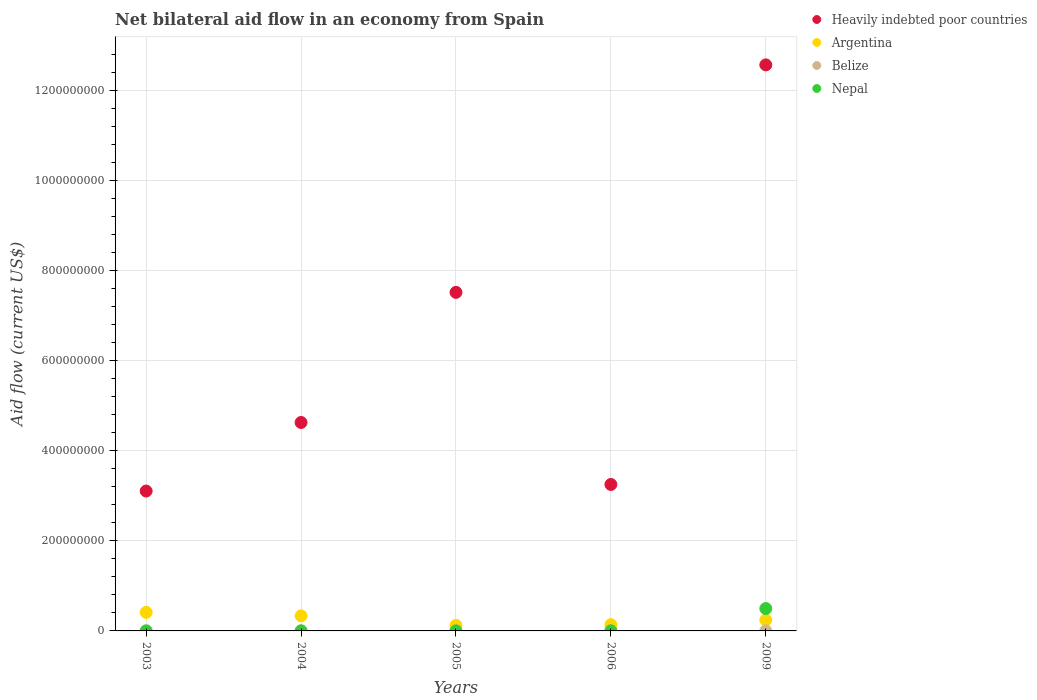How many different coloured dotlines are there?
Make the answer very short. 4. Across all years, what is the maximum net bilateral aid flow in Heavily indebted poor countries?
Your response must be concise. 1.26e+09. Across all years, what is the minimum net bilateral aid flow in Belize?
Your response must be concise. 0. In which year was the net bilateral aid flow in Nepal maximum?
Your answer should be very brief. 2009. What is the total net bilateral aid flow in Nepal in the graph?
Make the answer very short. 5.00e+07. What is the difference between the net bilateral aid flow in Nepal in 2003 and that in 2009?
Your answer should be compact. -4.96e+07. What is the difference between the net bilateral aid flow in Nepal in 2006 and the net bilateral aid flow in Heavily indebted poor countries in 2009?
Your answer should be compact. -1.26e+09. What is the average net bilateral aid flow in Nepal per year?
Make the answer very short. 1.00e+07. In the year 2005, what is the difference between the net bilateral aid flow in Belize and net bilateral aid flow in Argentina?
Make the answer very short. -1.21e+07. What is the ratio of the net bilateral aid flow in Nepal in 2004 to that in 2006?
Provide a succinct answer. 0.47. Is the net bilateral aid flow in Heavily indebted poor countries in 2006 less than that in 2009?
Give a very brief answer. Yes. Is the difference between the net bilateral aid flow in Belize in 2004 and 2006 greater than the difference between the net bilateral aid flow in Argentina in 2004 and 2006?
Ensure brevity in your answer.  No. What is the difference between the highest and the second highest net bilateral aid flow in Nepal?
Offer a very short reply. 4.94e+07. What is the difference between the highest and the lowest net bilateral aid flow in Nepal?
Offer a very short reply. 4.96e+07. In how many years, is the net bilateral aid flow in Argentina greater than the average net bilateral aid flow in Argentina taken over all years?
Ensure brevity in your answer.  2. Is it the case that in every year, the sum of the net bilateral aid flow in Argentina and net bilateral aid flow in Belize  is greater than the net bilateral aid flow in Heavily indebted poor countries?
Your response must be concise. No. How many dotlines are there?
Your answer should be compact. 4. Are the values on the major ticks of Y-axis written in scientific E-notation?
Give a very brief answer. No. Where does the legend appear in the graph?
Keep it short and to the point. Top right. How many legend labels are there?
Your answer should be compact. 4. What is the title of the graph?
Give a very brief answer. Net bilateral aid flow in an economy from Spain. Does "Aruba" appear as one of the legend labels in the graph?
Provide a short and direct response. No. What is the label or title of the X-axis?
Provide a short and direct response. Years. What is the label or title of the Y-axis?
Your answer should be compact. Aid flow (current US$). What is the Aid flow (current US$) in Heavily indebted poor countries in 2003?
Your response must be concise. 3.11e+08. What is the Aid flow (current US$) in Argentina in 2003?
Your response must be concise. 4.12e+07. What is the Aid flow (current US$) of Heavily indebted poor countries in 2004?
Make the answer very short. 4.63e+08. What is the Aid flow (current US$) of Argentina in 2004?
Provide a short and direct response. 3.34e+07. What is the Aid flow (current US$) of Heavily indebted poor countries in 2005?
Provide a short and direct response. 7.52e+08. What is the Aid flow (current US$) in Argentina in 2005?
Give a very brief answer. 1.23e+07. What is the Aid flow (current US$) in Nepal in 2005?
Provide a short and direct response. 1.00e+05. What is the Aid flow (current US$) of Heavily indebted poor countries in 2006?
Provide a succinct answer. 3.25e+08. What is the Aid flow (current US$) in Argentina in 2006?
Your response must be concise. 1.38e+07. What is the Aid flow (current US$) in Belize in 2006?
Offer a terse response. 2.00e+04. What is the Aid flow (current US$) of Nepal in 2006?
Offer a very short reply. 1.90e+05. What is the Aid flow (current US$) in Heavily indebted poor countries in 2009?
Your response must be concise. 1.26e+09. What is the Aid flow (current US$) of Argentina in 2009?
Your answer should be very brief. 2.41e+07. What is the Aid flow (current US$) in Belize in 2009?
Keep it short and to the point. 2.90e+05. What is the Aid flow (current US$) of Nepal in 2009?
Offer a very short reply. 4.96e+07. Across all years, what is the maximum Aid flow (current US$) of Heavily indebted poor countries?
Provide a short and direct response. 1.26e+09. Across all years, what is the maximum Aid flow (current US$) in Argentina?
Provide a succinct answer. 4.12e+07. Across all years, what is the maximum Aid flow (current US$) of Nepal?
Your answer should be compact. 4.96e+07. Across all years, what is the minimum Aid flow (current US$) in Heavily indebted poor countries?
Ensure brevity in your answer.  3.11e+08. Across all years, what is the minimum Aid flow (current US$) in Argentina?
Provide a succinct answer. 1.23e+07. Across all years, what is the minimum Aid flow (current US$) in Belize?
Keep it short and to the point. 0. What is the total Aid flow (current US$) in Heavily indebted poor countries in the graph?
Ensure brevity in your answer.  3.11e+09. What is the total Aid flow (current US$) of Argentina in the graph?
Offer a very short reply. 1.25e+08. What is the total Aid flow (current US$) of Belize in the graph?
Offer a very short reply. 7.40e+05. What is the total Aid flow (current US$) in Nepal in the graph?
Keep it short and to the point. 5.00e+07. What is the difference between the Aid flow (current US$) of Heavily indebted poor countries in 2003 and that in 2004?
Keep it short and to the point. -1.52e+08. What is the difference between the Aid flow (current US$) of Argentina in 2003 and that in 2004?
Provide a succinct answer. 7.77e+06. What is the difference between the Aid flow (current US$) in Heavily indebted poor countries in 2003 and that in 2005?
Make the answer very short. -4.41e+08. What is the difference between the Aid flow (current US$) of Argentina in 2003 and that in 2005?
Provide a succinct answer. 2.88e+07. What is the difference between the Aid flow (current US$) of Heavily indebted poor countries in 2003 and that in 2006?
Provide a succinct answer. -1.46e+07. What is the difference between the Aid flow (current US$) of Argentina in 2003 and that in 2006?
Provide a succinct answer. 2.73e+07. What is the difference between the Aid flow (current US$) in Heavily indebted poor countries in 2003 and that in 2009?
Your answer should be very brief. -9.46e+08. What is the difference between the Aid flow (current US$) in Argentina in 2003 and that in 2009?
Keep it short and to the point. 1.70e+07. What is the difference between the Aid flow (current US$) in Nepal in 2003 and that in 2009?
Your answer should be very brief. -4.96e+07. What is the difference between the Aid flow (current US$) in Heavily indebted poor countries in 2004 and that in 2005?
Keep it short and to the point. -2.89e+08. What is the difference between the Aid flow (current US$) in Argentina in 2004 and that in 2005?
Make the answer very short. 2.11e+07. What is the difference between the Aid flow (current US$) in Nepal in 2004 and that in 2005?
Keep it short and to the point. -10000. What is the difference between the Aid flow (current US$) of Heavily indebted poor countries in 2004 and that in 2006?
Your answer should be very brief. 1.38e+08. What is the difference between the Aid flow (current US$) in Argentina in 2004 and that in 2006?
Keep it short and to the point. 1.96e+07. What is the difference between the Aid flow (current US$) in Belize in 2004 and that in 2006?
Ensure brevity in your answer.  1.60e+05. What is the difference between the Aid flow (current US$) of Nepal in 2004 and that in 2006?
Your answer should be compact. -1.00e+05. What is the difference between the Aid flow (current US$) in Heavily indebted poor countries in 2004 and that in 2009?
Provide a succinct answer. -7.94e+08. What is the difference between the Aid flow (current US$) of Argentina in 2004 and that in 2009?
Your response must be concise. 9.25e+06. What is the difference between the Aid flow (current US$) in Belize in 2004 and that in 2009?
Ensure brevity in your answer.  -1.10e+05. What is the difference between the Aid flow (current US$) of Nepal in 2004 and that in 2009?
Give a very brief answer. -4.95e+07. What is the difference between the Aid flow (current US$) of Heavily indebted poor countries in 2005 and that in 2006?
Your answer should be very brief. 4.26e+08. What is the difference between the Aid flow (current US$) in Argentina in 2005 and that in 2006?
Ensure brevity in your answer.  -1.50e+06. What is the difference between the Aid flow (current US$) in Heavily indebted poor countries in 2005 and that in 2009?
Give a very brief answer. -5.05e+08. What is the difference between the Aid flow (current US$) of Argentina in 2005 and that in 2009?
Offer a very short reply. -1.18e+07. What is the difference between the Aid flow (current US$) of Nepal in 2005 and that in 2009?
Make the answer very short. -4.95e+07. What is the difference between the Aid flow (current US$) in Heavily indebted poor countries in 2006 and that in 2009?
Ensure brevity in your answer.  -9.31e+08. What is the difference between the Aid flow (current US$) of Argentina in 2006 and that in 2009?
Your answer should be compact. -1.03e+07. What is the difference between the Aid flow (current US$) in Nepal in 2006 and that in 2009?
Ensure brevity in your answer.  -4.94e+07. What is the difference between the Aid flow (current US$) in Heavily indebted poor countries in 2003 and the Aid flow (current US$) in Argentina in 2004?
Your answer should be compact. 2.77e+08. What is the difference between the Aid flow (current US$) of Heavily indebted poor countries in 2003 and the Aid flow (current US$) of Belize in 2004?
Your response must be concise. 3.10e+08. What is the difference between the Aid flow (current US$) of Heavily indebted poor countries in 2003 and the Aid flow (current US$) of Nepal in 2004?
Keep it short and to the point. 3.10e+08. What is the difference between the Aid flow (current US$) of Argentina in 2003 and the Aid flow (current US$) of Belize in 2004?
Provide a short and direct response. 4.10e+07. What is the difference between the Aid flow (current US$) of Argentina in 2003 and the Aid flow (current US$) of Nepal in 2004?
Offer a very short reply. 4.11e+07. What is the difference between the Aid flow (current US$) in Heavily indebted poor countries in 2003 and the Aid flow (current US$) in Argentina in 2005?
Give a very brief answer. 2.98e+08. What is the difference between the Aid flow (current US$) in Heavily indebted poor countries in 2003 and the Aid flow (current US$) in Belize in 2005?
Provide a short and direct response. 3.10e+08. What is the difference between the Aid flow (current US$) in Heavily indebted poor countries in 2003 and the Aid flow (current US$) in Nepal in 2005?
Ensure brevity in your answer.  3.10e+08. What is the difference between the Aid flow (current US$) of Argentina in 2003 and the Aid flow (current US$) of Belize in 2005?
Your answer should be very brief. 4.09e+07. What is the difference between the Aid flow (current US$) of Argentina in 2003 and the Aid flow (current US$) of Nepal in 2005?
Your answer should be very brief. 4.11e+07. What is the difference between the Aid flow (current US$) of Heavily indebted poor countries in 2003 and the Aid flow (current US$) of Argentina in 2006?
Provide a succinct answer. 2.97e+08. What is the difference between the Aid flow (current US$) of Heavily indebted poor countries in 2003 and the Aid flow (current US$) of Belize in 2006?
Provide a succinct answer. 3.10e+08. What is the difference between the Aid flow (current US$) in Heavily indebted poor countries in 2003 and the Aid flow (current US$) in Nepal in 2006?
Your answer should be compact. 3.10e+08. What is the difference between the Aid flow (current US$) of Argentina in 2003 and the Aid flow (current US$) of Belize in 2006?
Provide a short and direct response. 4.11e+07. What is the difference between the Aid flow (current US$) in Argentina in 2003 and the Aid flow (current US$) in Nepal in 2006?
Keep it short and to the point. 4.10e+07. What is the difference between the Aid flow (current US$) of Heavily indebted poor countries in 2003 and the Aid flow (current US$) of Argentina in 2009?
Make the answer very short. 2.86e+08. What is the difference between the Aid flow (current US$) in Heavily indebted poor countries in 2003 and the Aid flow (current US$) in Belize in 2009?
Offer a terse response. 3.10e+08. What is the difference between the Aid flow (current US$) of Heavily indebted poor countries in 2003 and the Aid flow (current US$) of Nepal in 2009?
Your response must be concise. 2.61e+08. What is the difference between the Aid flow (current US$) in Argentina in 2003 and the Aid flow (current US$) in Belize in 2009?
Provide a short and direct response. 4.09e+07. What is the difference between the Aid flow (current US$) in Argentina in 2003 and the Aid flow (current US$) in Nepal in 2009?
Provide a succinct answer. -8.46e+06. What is the difference between the Aid flow (current US$) in Heavily indebted poor countries in 2004 and the Aid flow (current US$) in Argentina in 2005?
Provide a short and direct response. 4.50e+08. What is the difference between the Aid flow (current US$) of Heavily indebted poor countries in 2004 and the Aid flow (current US$) of Belize in 2005?
Ensure brevity in your answer.  4.62e+08. What is the difference between the Aid flow (current US$) of Heavily indebted poor countries in 2004 and the Aid flow (current US$) of Nepal in 2005?
Offer a terse response. 4.63e+08. What is the difference between the Aid flow (current US$) of Argentina in 2004 and the Aid flow (current US$) of Belize in 2005?
Offer a very short reply. 3.31e+07. What is the difference between the Aid flow (current US$) in Argentina in 2004 and the Aid flow (current US$) in Nepal in 2005?
Give a very brief answer. 3.33e+07. What is the difference between the Aid flow (current US$) in Heavily indebted poor countries in 2004 and the Aid flow (current US$) in Argentina in 2006?
Provide a succinct answer. 4.49e+08. What is the difference between the Aid flow (current US$) of Heavily indebted poor countries in 2004 and the Aid flow (current US$) of Belize in 2006?
Your answer should be compact. 4.63e+08. What is the difference between the Aid flow (current US$) in Heavily indebted poor countries in 2004 and the Aid flow (current US$) in Nepal in 2006?
Give a very brief answer. 4.62e+08. What is the difference between the Aid flow (current US$) in Argentina in 2004 and the Aid flow (current US$) in Belize in 2006?
Offer a very short reply. 3.34e+07. What is the difference between the Aid flow (current US$) of Argentina in 2004 and the Aid flow (current US$) of Nepal in 2006?
Provide a succinct answer. 3.32e+07. What is the difference between the Aid flow (current US$) in Heavily indebted poor countries in 2004 and the Aid flow (current US$) in Argentina in 2009?
Provide a succinct answer. 4.39e+08. What is the difference between the Aid flow (current US$) in Heavily indebted poor countries in 2004 and the Aid flow (current US$) in Belize in 2009?
Offer a terse response. 4.62e+08. What is the difference between the Aid flow (current US$) of Heavily indebted poor countries in 2004 and the Aid flow (current US$) of Nepal in 2009?
Provide a short and direct response. 4.13e+08. What is the difference between the Aid flow (current US$) in Argentina in 2004 and the Aid flow (current US$) in Belize in 2009?
Your response must be concise. 3.31e+07. What is the difference between the Aid flow (current US$) of Argentina in 2004 and the Aid flow (current US$) of Nepal in 2009?
Your response must be concise. -1.62e+07. What is the difference between the Aid flow (current US$) of Belize in 2004 and the Aid flow (current US$) of Nepal in 2009?
Make the answer very short. -4.94e+07. What is the difference between the Aid flow (current US$) in Heavily indebted poor countries in 2005 and the Aid flow (current US$) in Argentina in 2006?
Ensure brevity in your answer.  7.38e+08. What is the difference between the Aid flow (current US$) in Heavily indebted poor countries in 2005 and the Aid flow (current US$) in Belize in 2006?
Provide a succinct answer. 7.52e+08. What is the difference between the Aid flow (current US$) of Heavily indebted poor countries in 2005 and the Aid flow (current US$) of Nepal in 2006?
Your answer should be compact. 7.51e+08. What is the difference between the Aid flow (current US$) of Argentina in 2005 and the Aid flow (current US$) of Belize in 2006?
Your response must be concise. 1.23e+07. What is the difference between the Aid flow (current US$) of Argentina in 2005 and the Aid flow (current US$) of Nepal in 2006?
Give a very brief answer. 1.21e+07. What is the difference between the Aid flow (current US$) in Heavily indebted poor countries in 2005 and the Aid flow (current US$) in Argentina in 2009?
Provide a succinct answer. 7.27e+08. What is the difference between the Aid flow (current US$) of Heavily indebted poor countries in 2005 and the Aid flow (current US$) of Belize in 2009?
Offer a terse response. 7.51e+08. What is the difference between the Aid flow (current US$) of Heavily indebted poor countries in 2005 and the Aid flow (current US$) of Nepal in 2009?
Your response must be concise. 7.02e+08. What is the difference between the Aid flow (current US$) in Argentina in 2005 and the Aid flow (current US$) in Belize in 2009?
Your answer should be compact. 1.20e+07. What is the difference between the Aid flow (current US$) in Argentina in 2005 and the Aid flow (current US$) in Nepal in 2009?
Make the answer very short. -3.73e+07. What is the difference between the Aid flow (current US$) of Belize in 2005 and the Aid flow (current US$) of Nepal in 2009?
Make the answer very short. -4.94e+07. What is the difference between the Aid flow (current US$) in Heavily indebted poor countries in 2006 and the Aid flow (current US$) in Argentina in 2009?
Offer a terse response. 3.01e+08. What is the difference between the Aid flow (current US$) of Heavily indebted poor countries in 2006 and the Aid flow (current US$) of Belize in 2009?
Make the answer very short. 3.25e+08. What is the difference between the Aid flow (current US$) of Heavily indebted poor countries in 2006 and the Aid flow (current US$) of Nepal in 2009?
Provide a succinct answer. 2.75e+08. What is the difference between the Aid flow (current US$) in Argentina in 2006 and the Aid flow (current US$) in Belize in 2009?
Your answer should be compact. 1.35e+07. What is the difference between the Aid flow (current US$) in Argentina in 2006 and the Aid flow (current US$) in Nepal in 2009?
Keep it short and to the point. -3.58e+07. What is the difference between the Aid flow (current US$) in Belize in 2006 and the Aid flow (current US$) in Nepal in 2009?
Make the answer very short. -4.96e+07. What is the average Aid flow (current US$) of Heavily indebted poor countries per year?
Your answer should be compact. 6.21e+08. What is the average Aid flow (current US$) in Argentina per year?
Your answer should be very brief. 2.50e+07. What is the average Aid flow (current US$) in Belize per year?
Keep it short and to the point. 1.48e+05. What is the average Aid flow (current US$) in Nepal per year?
Offer a very short reply. 1.00e+07. In the year 2003, what is the difference between the Aid flow (current US$) in Heavily indebted poor countries and Aid flow (current US$) in Argentina?
Provide a succinct answer. 2.69e+08. In the year 2003, what is the difference between the Aid flow (current US$) in Heavily indebted poor countries and Aid flow (current US$) in Nepal?
Your response must be concise. 3.10e+08. In the year 2003, what is the difference between the Aid flow (current US$) of Argentina and Aid flow (current US$) of Nepal?
Your response must be concise. 4.11e+07. In the year 2004, what is the difference between the Aid flow (current US$) in Heavily indebted poor countries and Aid flow (current US$) in Argentina?
Your answer should be very brief. 4.29e+08. In the year 2004, what is the difference between the Aid flow (current US$) of Heavily indebted poor countries and Aid flow (current US$) of Belize?
Your answer should be compact. 4.62e+08. In the year 2004, what is the difference between the Aid flow (current US$) of Heavily indebted poor countries and Aid flow (current US$) of Nepal?
Keep it short and to the point. 4.63e+08. In the year 2004, what is the difference between the Aid flow (current US$) of Argentina and Aid flow (current US$) of Belize?
Make the answer very short. 3.32e+07. In the year 2004, what is the difference between the Aid flow (current US$) of Argentina and Aid flow (current US$) of Nepal?
Your answer should be compact. 3.33e+07. In the year 2004, what is the difference between the Aid flow (current US$) in Belize and Aid flow (current US$) in Nepal?
Ensure brevity in your answer.  9.00e+04. In the year 2005, what is the difference between the Aid flow (current US$) of Heavily indebted poor countries and Aid flow (current US$) of Argentina?
Your answer should be compact. 7.39e+08. In the year 2005, what is the difference between the Aid flow (current US$) of Heavily indebted poor countries and Aid flow (current US$) of Belize?
Offer a very short reply. 7.51e+08. In the year 2005, what is the difference between the Aid flow (current US$) of Heavily indebted poor countries and Aid flow (current US$) of Nepal?
Your answer should be compact. 7.51e+08. In the year 2005, what is the difference between the Aid flow (current US$) of Argentina and Aid flow (current US$) of Belize?
Ensure brevity in your answer.  1.21e+07. In the year 2005, what is the difference between the Aid flow (current US$) of Argentina and Aid flow (current US$) of Nepal?
Provide a succinct answer. 1.22e+07. In the year 2005, what is the difference between the Aid flow (current US$) in Belize and Aid flow (current US$) in Nepal?
Ensure brevity in your answer.  1.50e+05. In the year 2006, what is the difference between the Aid flow (current US$) in Heavily indebted poor countries and Aid flow (current US$) in Argentina?
Offer a very short reply. 3.11e+08. In the year 2006, what is the difference between the Aid flow (current US$) in Heavily indebted poor countries and Aid flow (current US$) in Belize?
Your response must be concise. 3.25e+08. In the year 2006, what is the difference between the Aid flow (current US$) of Heavily indebted poor countries and Aid flow (current US$) of Nepal?
Offer a terse response. 3.25e+08. In the year 2006, what is the difference between the Aid flow (current US$) of Argentina and Aid flow (current US$) of Belize?
Keep it short and to the point. 1.38e+07. In the year 2006, what is the difference between the Aid flow (current US$) in Argentina and Aid flow (current US$) in Nepal?
Provide a succinct answer. 1.36e+07. In the year 2009, what is the difference between the Aid flow (current US$) in Heavily indebted poor countries and Aid flow (current US$) in Argentina?
Offer a very short reply. 1.23e+09. In the year 2009, what is the difference between the Aid flow (current US$) in Heavily indebted poor countries and Aid flow (current US$) in Belize?
Give a very brief answer. 1.26e+09. In the year 2009, what is the difference between the Aid flow (current US$) of Heavily indebted poor countries and Aid flow (current US$) of Nepal?
Provide a short and direct response. 1.21e+09. In the year 2009, what is the difference between the Aid flow (current US$) of Argentina and Aid flow (current US$) of Belize?
Provide a short and direct response. 2.38e+07. In the year 2009, what is the difference between the Aid flow (current US$) of Argentina and Aid flow (current US$) of Nepal?
Keep it short and to the point. -2.55e+07. In the year 2009, what is the difference between the Aid flow (current US$) in Belize and Aid flow (current US$) in Nepal?
Offer a terse response. -4.93e+07. What is the ratio of the Aid flow (current US$) in Heavily indebted poor countries in 2003 to that in 2004?
Provide a short and direct response. 0.67. What is the ratio of the Aid flow (current US$) of Argentina in 2003 to that in 2004?
Give a very brief answer. 1.23. What is the ratio of the Aid flow (current US$) of Nepal in 2003 to that in 2004?
Your response must be concise. 0.44. What is the ratio of the Aid flow (current US$) of Heavily indebted poor countries in 2003 to that in 2005?
Provide a short and direct response. 0.41. What is the ratio of the Aid flow (current US$) in Argentina in 2003 to that in 2005?
Your answer should be compact. 3.34. What is the ratio of the Aid flow (current US$) of Heavily indebted poor countries in 2003 to that in 2006?
Provide a succinct answer. 0.96. What is the ratio of the Aid flow (current US$) in Argentina in 2003 to that in 2006?
Offer a very short reply. 2.98. What is the ratio of the Aid flow (current US$) of Nepal in 2003 to that in 2006?
Your response must be concise. 0.21. What is the ratio of the Aid flow (current US$) of Heavily indebted poor countries in 2003 to that in 2009?
Ensure brevity in your answer.  0.25. What is the ratio of the Aid flow (current US$) of Argentina in 2003 to that in 2009?
Keep it short and to the point. 1.71. What is the ratio of the Aid flow (current US$) of Nepal in 2003 to that in 2009?
Offer a very short reply. 0. What is the ratio of the Aid flow (current US$) in Heavily indebted poor countries in 2004 to that in 2005?
Keep it short and to the point. 0.62. What is the ratio of the Aid flow (current US$) in Argentina in 2004 to that in 2005?
Ensure brevity in your answer.  2.71. What is the ratio of the Aid flow (current US$) in Belize in 2004 to that in 2005?
Make the answer very short. 0.72. What is the ratio of the Aid flow (current US$) of Heavily indebted poor countries in 2004 to that in 2006?
Provide a short and direct response. 1.42. What is the ratio of the Aid flow (current US$) of Argentina in 2004 to that in 2006?
Your response must be concise. 2.41. What is the ratio of the Aid flow (current US$) of Belize in 2004 to that in 2006?
Offer a very short reply. 9. What is the ratio of the Aid flow (current US$) in Nepal in 2004 to that in 2006?
Keep it short and to the point. 0.47. What is the ratio of the Aid flow (current US$) in Heavily indebted poor countries in 2004 to that in 2009?
Your answer should be very brief. 0.37. What is the ratio of the Aid flow (current US$) in Argentina in 2004 to that in 2009?
Make the answer very short. 1.38. What is the ratio of the Aid flow (current US$) of Belize in 2004 to that in 2009?
Offer a terse response. 0.62. What is the ratio of the Aid flow (current US$) in Nepal in 2004 to that in 2009?
Ensure brevity in your answer.  0. What is the ratio of the Aid flow (current US$) of Heavily indebted poor countries in 2005 to that in 2006?
Give a very brief answer. 2.31. What is the ratio of the Aid flow (current US$) of Argentina in 2005 to that in 2006?
Your answer should be compact. 0.89. What is the ratio of the Aid flow (current US$) in Nepal in 2005 to that in 2006?
Offer a very short reply. 0.53. What is the ratio of the Aid flow (current US$) in Heavily indebted poor countries in 2005 to that in 2009?
Offer a very short reply. 0.6. What is the ratio of the Aid flow (current US$) in Argentina in 2005 to that in 2009?
Provide a short and direct response. 0.51. What is the ratio of the Aid flow (current US$) of Belize in 2005 to that in 2009?
Your answer should be very brief. 0.86. What is the ratio of the Aid flow (current US$) in Nepal in 2005 to that in 2009?
Provide a short and direct response. 0. What is the ratio of the Aid flow (current US$) of Heavily indebted poor countries in 2006 to that in 2009?
Give a very brief answer. 0.26. What is the ratio of the Aid flow (current US$) of Argentina in 2006 to that in 2009?
Your answer should be compact. 0.57. What is the ratio of the Aid flow (current US$) in Belize in 2006 to that in 2009?
Your answer should be very brief. 0.07. What is the ratio of the Aid flow (current US$) in Nepal in 2006 to that in 2009?
Provide a short and direct response. 0. What is the difference between the highest and the second highest Aid flow (current US$) in Heavily indebted poor countries?
Ensure brevity in your answer.  5.05e+08. What is the difference between the highest and the second highest Aid flow (current US$) of Argentina?
Your response must be concise. 7.77e+06. What is the difference between the highest and the second highest Aid flow (current US$) of Nepal?
Give a very brief answer. 4.94e+07. What is the difference between the highest and the lowest Aid flow (current US$) in Heavily indebted poor countries?
Offer a terse response. 9.46e+08. What is the difference between the highest and the lowest Aid flow (current US$) in Argentina?
Keep it short and to the point. 2.88e+07. What is the difference between the highest and the lowest Aid flow (current US$) of Nepal?
Make the answer very short. 4.96e+07. 